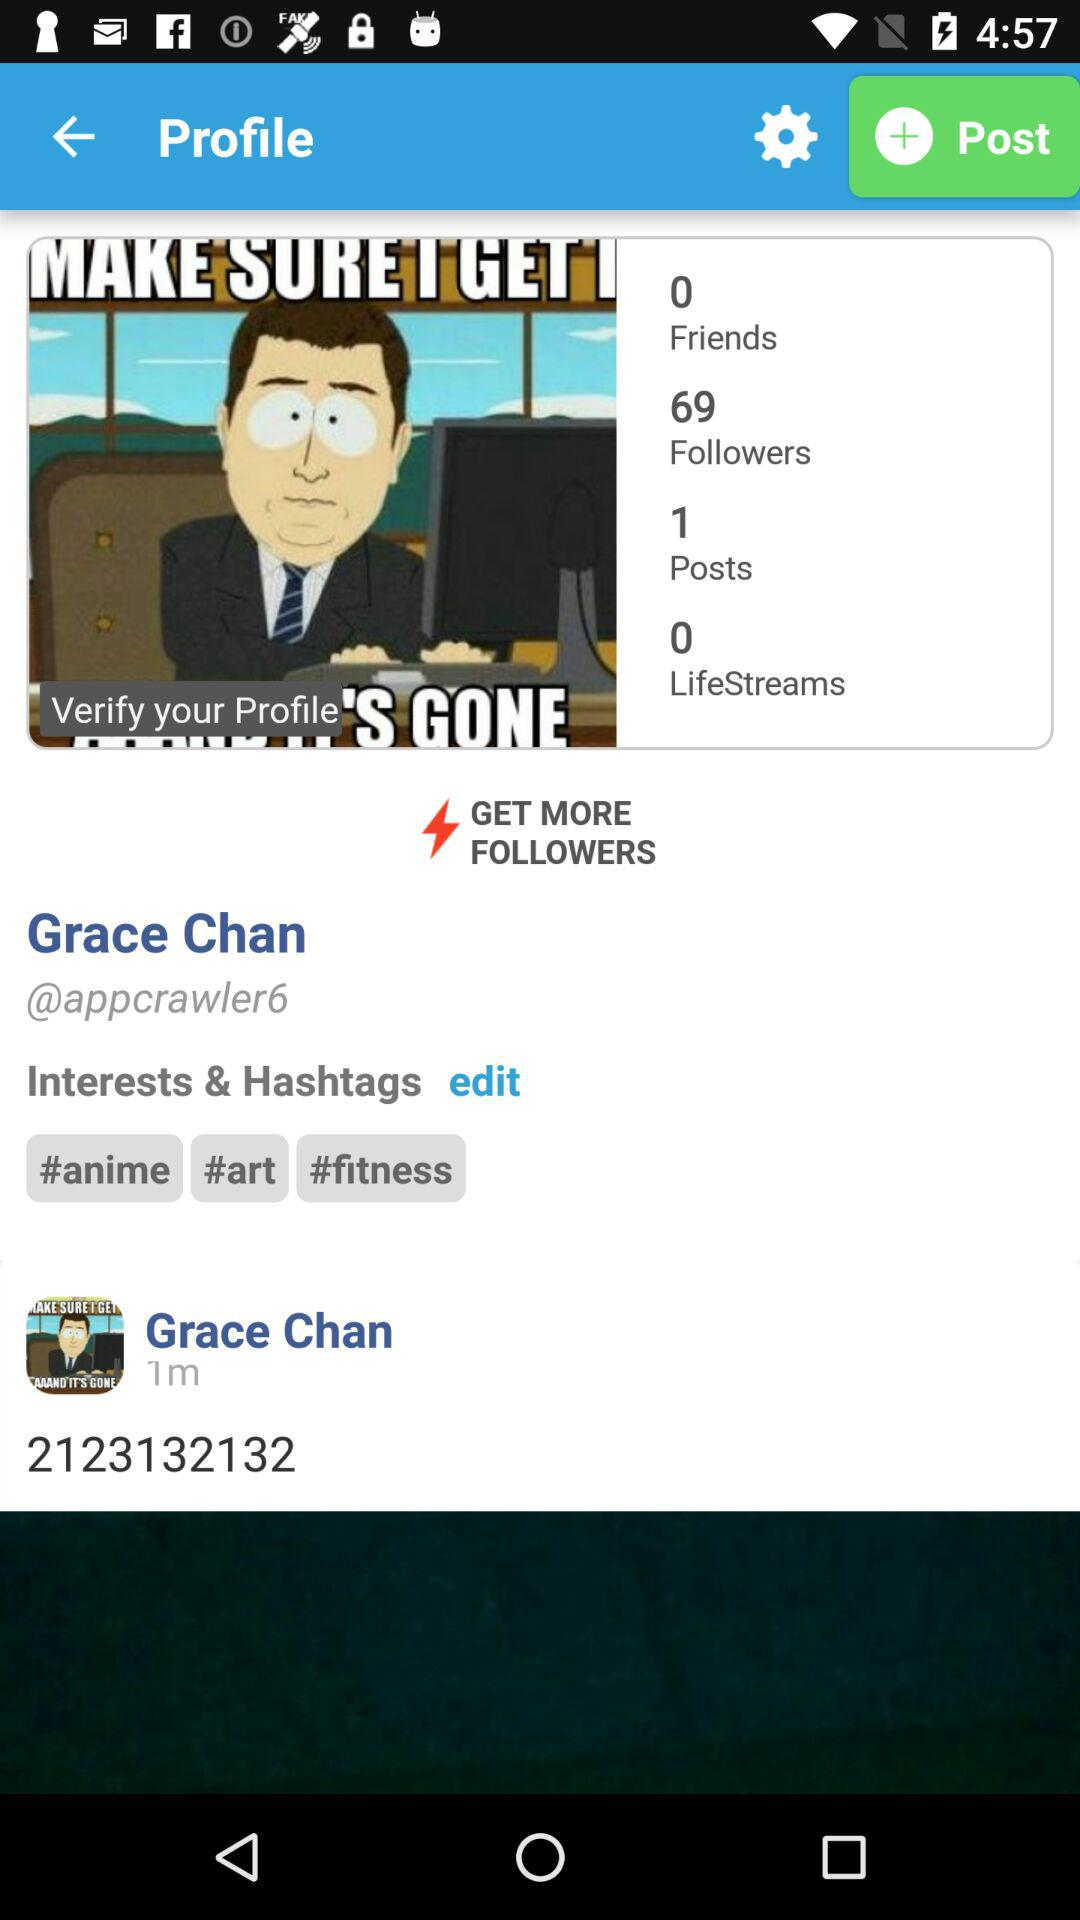What's the number mentioned in the post posted by Grace Chan? The number mentioned in the post is 2123132132. 